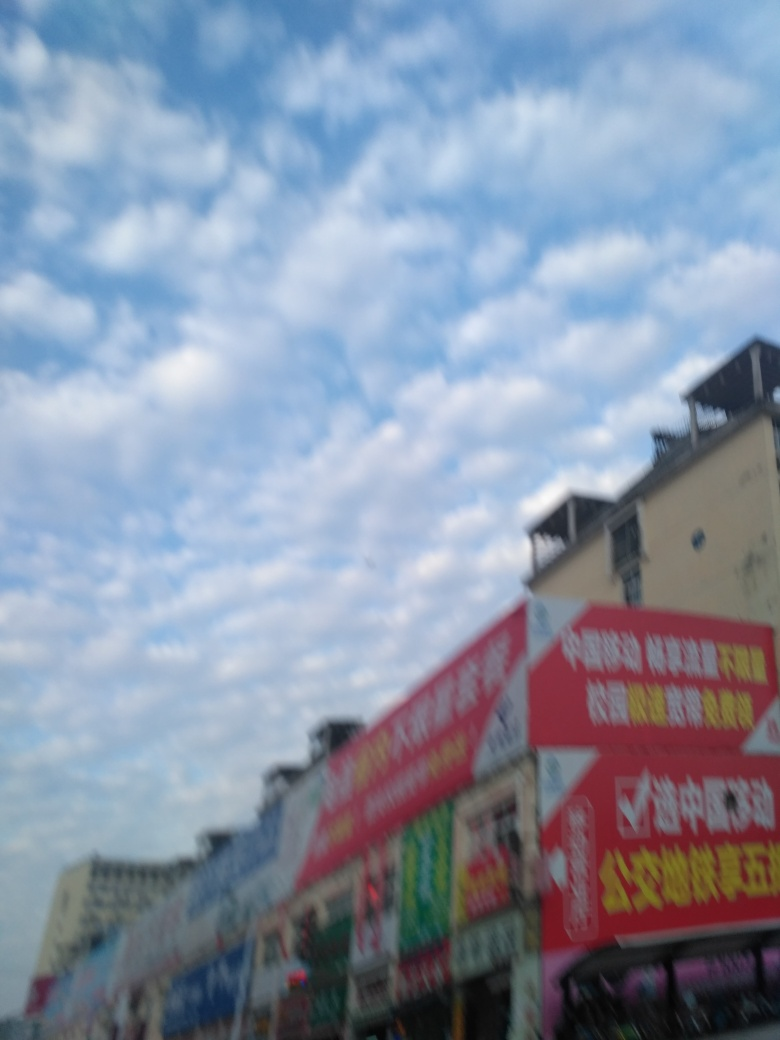Can you tell me more about the text on the red banners? The text on the banners is not clear due to the blurriness of the image. However, they seem to be advertisements or storefront signage, which is typical for shops to attract customers with their offers or services. 